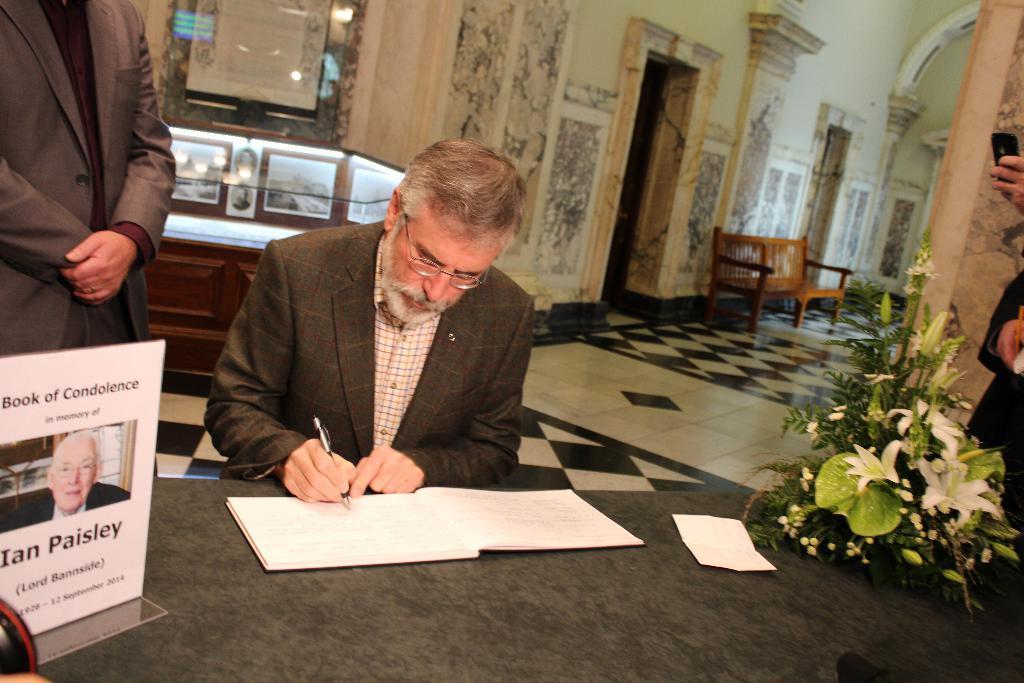Can you describe this image briefly? In this picture there is a man who is sitting in the center of the image, he is writing in a book, which is placed on a table and there is a bouquet and a magazine magazine on a table, there are other people in the image, there are doors, a bench, desk and a portrait in the background area of the image. 